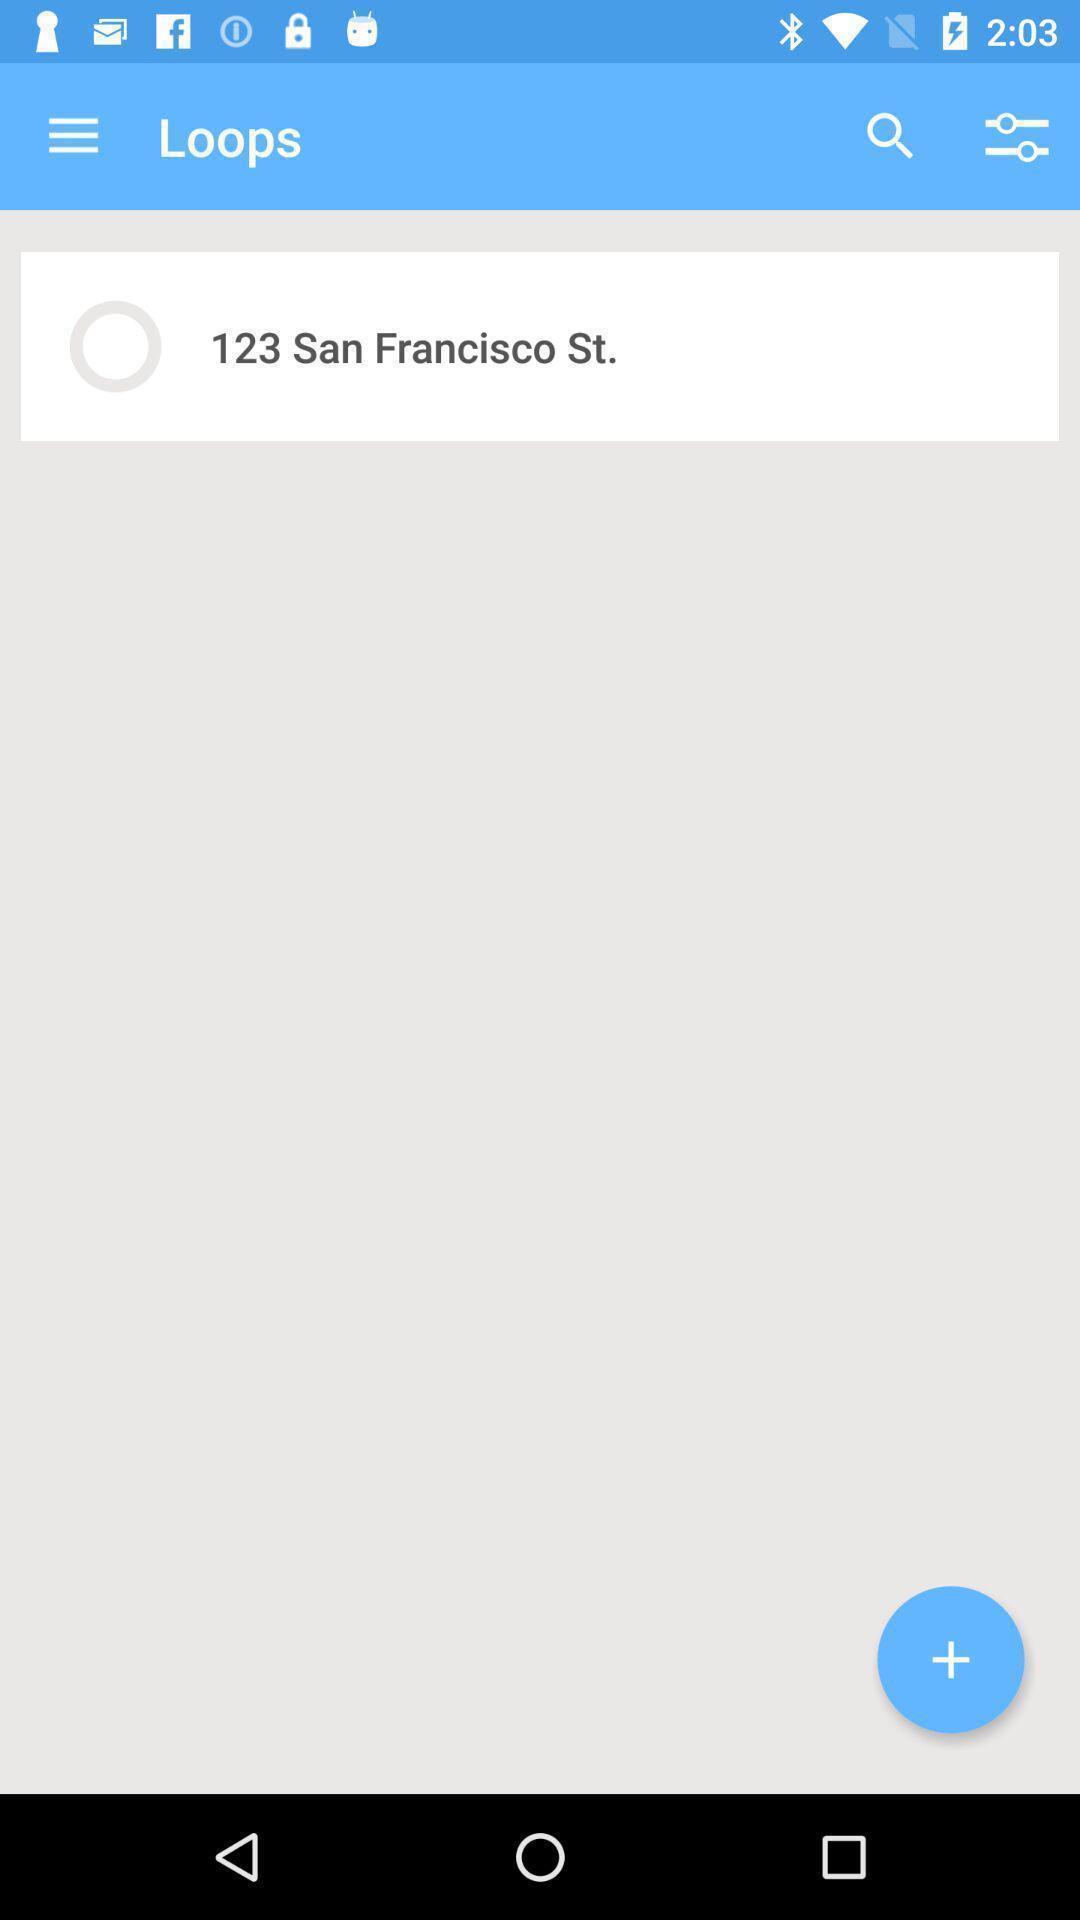Summarize the main components in this picture. Search bar for different loops. 